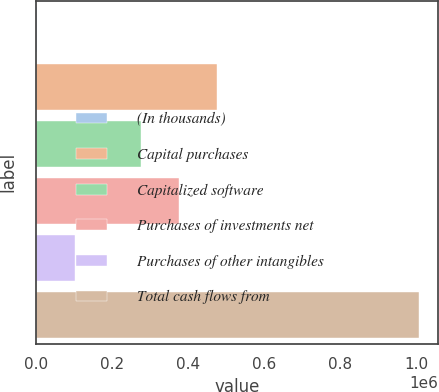<chart> <loc_0><loc_0><loc_500><loc_500><bar_chart><fcel>(In thousands)<fcel>Capital purchases<fcel>Capitalized software<fcel>Purchases of investments net<fcel>Purchases of other intangibles<fcel>Total cash flows from<nl><fcel>2017<fcel>474915<fcel>274148<fcel>374531<fcel>102400<fcel>1.00585e+06<nl></chart> 